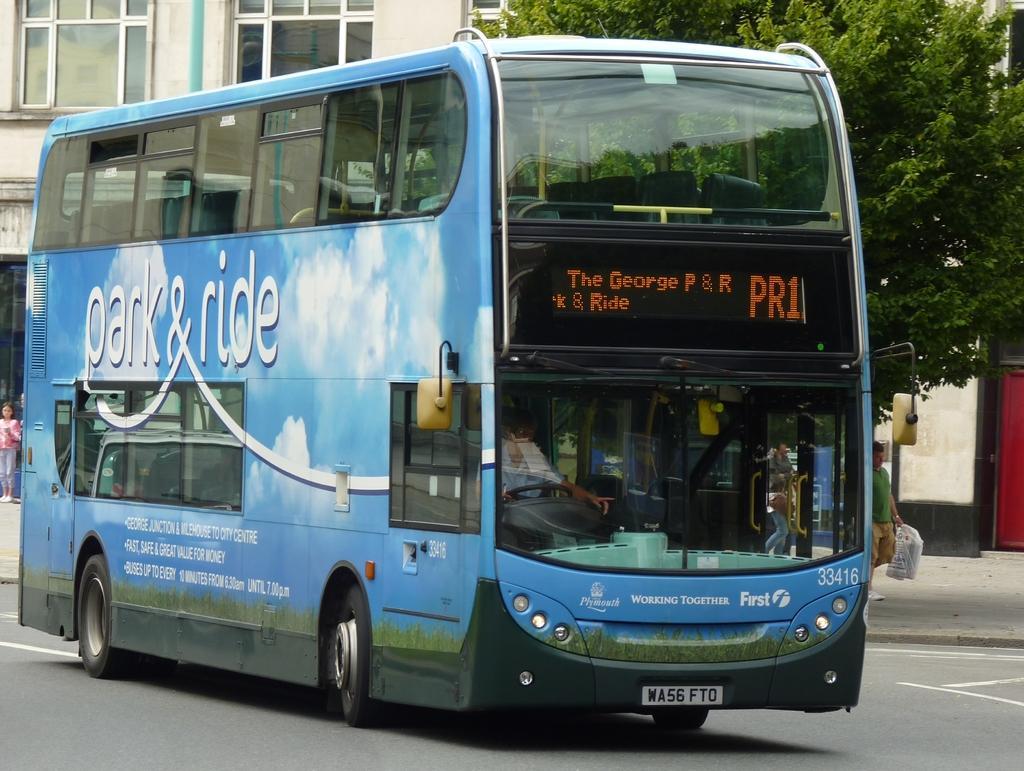How would you summarize this image in a sentence or two? In the foreground I can see a bus and a group of people on the road. In the background I can see buildings and a tree. This image is taken on the road. 